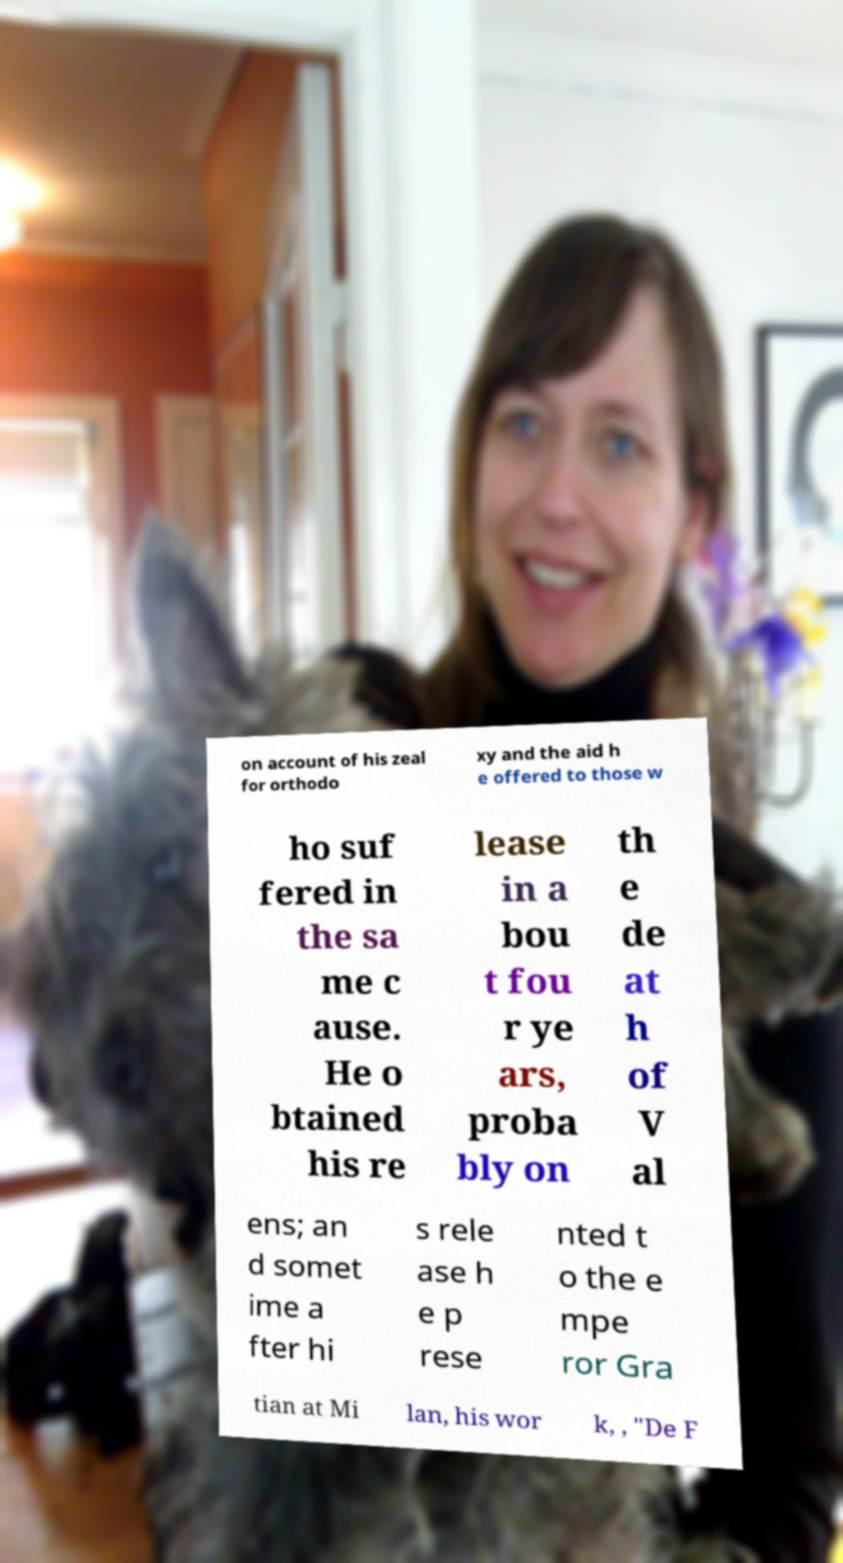Can you accurately transcribe the text from the provided image for me? on account of his zeal for orthodo xy and the aid h e offered to those w ho suf fered in the sa me c ause. He o btained his re lease in a bou t fou r ye ars, proba bly on th e de at h of V al ens; an d somet ime a fter hi s rele ase h e p rese nted t o the e mpe ror Gra tian at Mi lan, his wor k, , "De F 